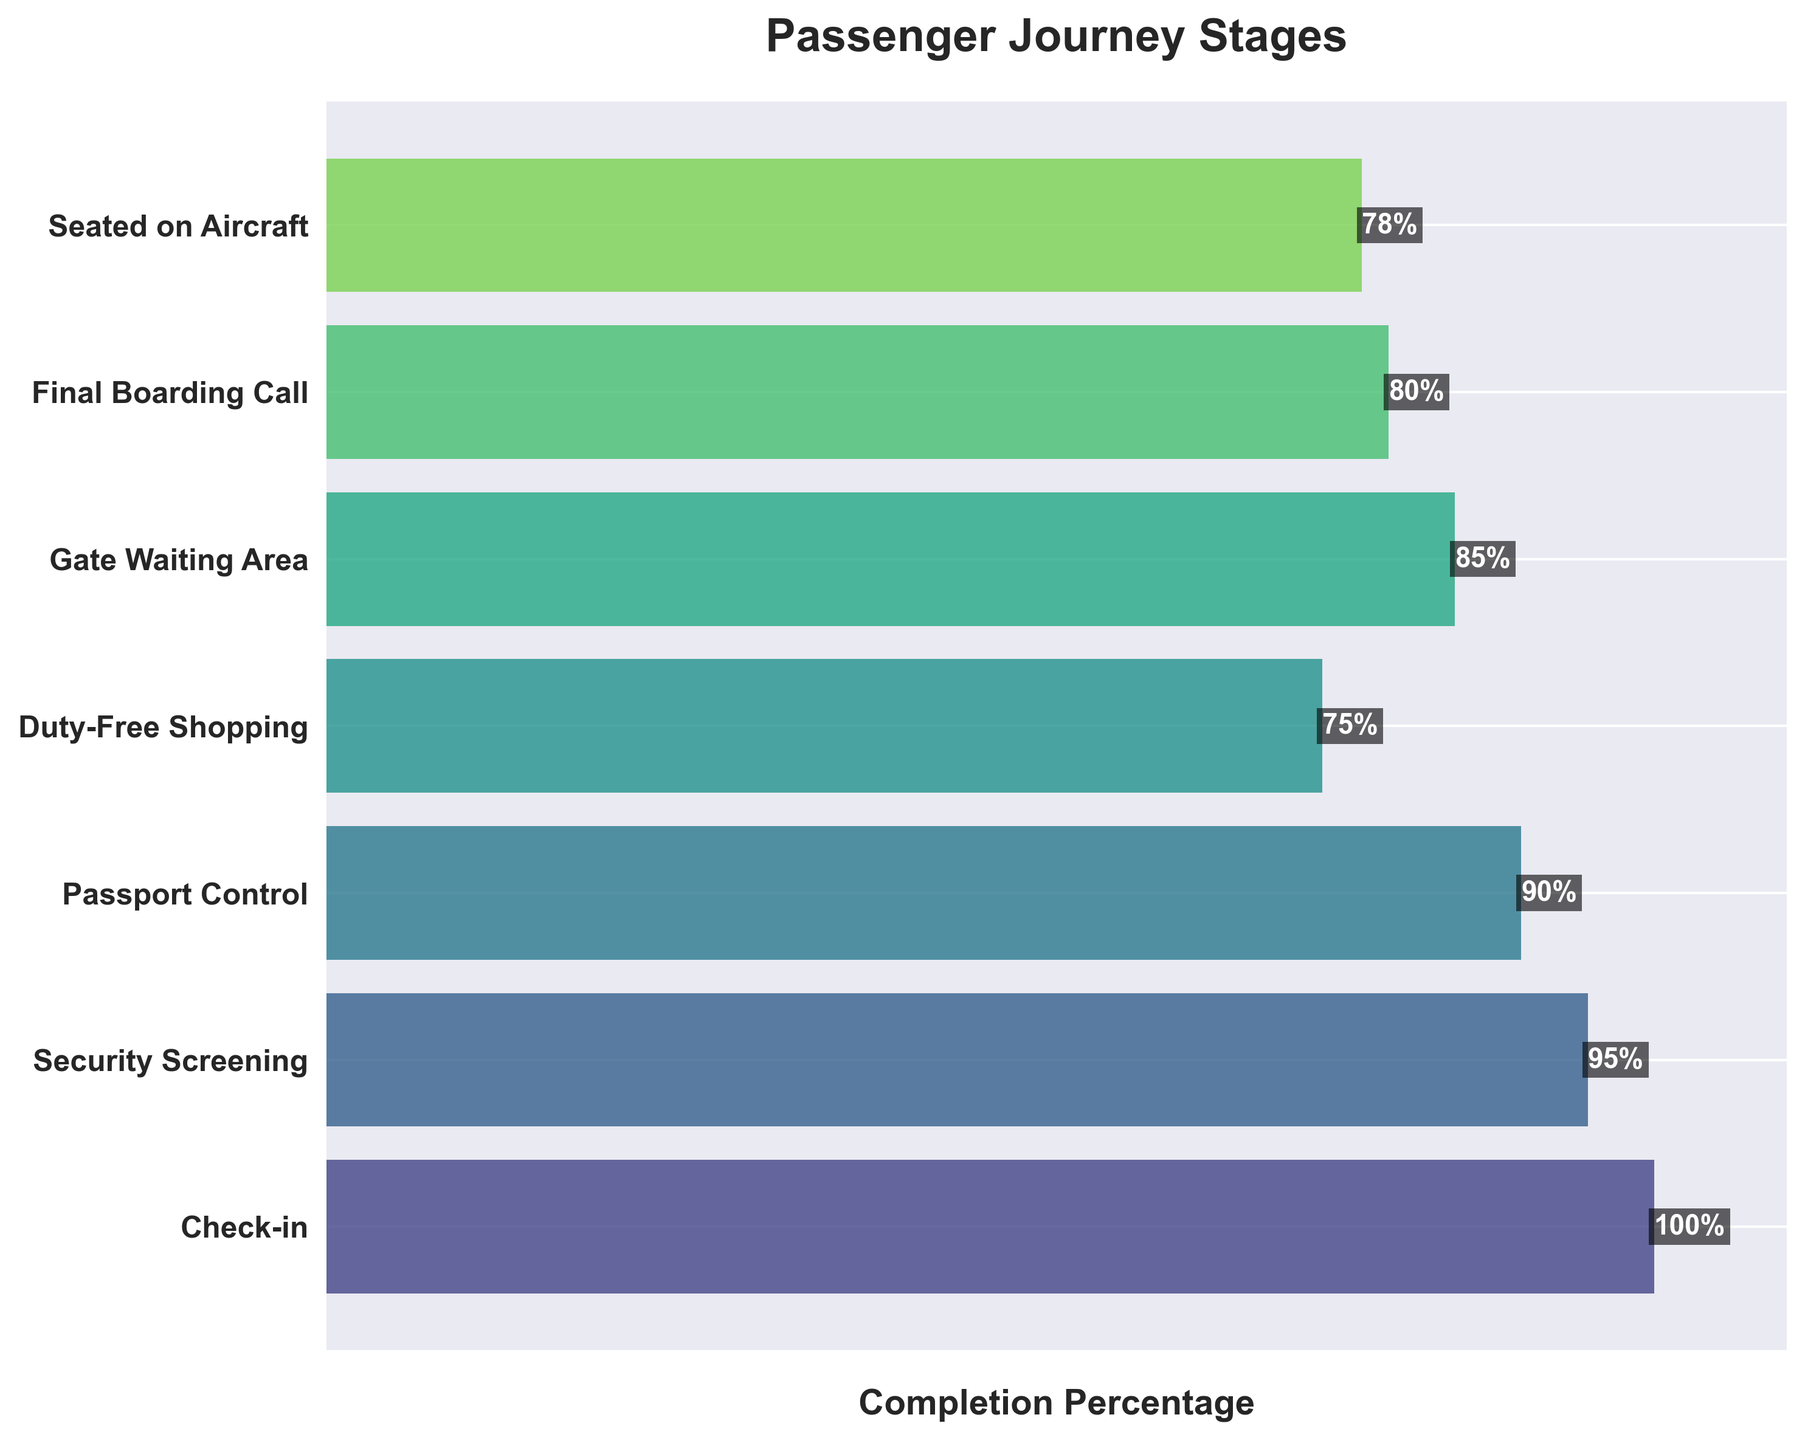What is the title of the figure? The title of the figure is displayed at the top and summarizes the content of the chart.
Answer: Passenger Journey Stages What is the percentage completion at the Security Screening stage? The Security Screening stage is labeled on the y-axis and the percentage completion is shown as a value inside the bar for that stage.
Answer: 95% How many stages are there in total? Count the number of distinct stages listed on the y-axis.
Answer: 7 Which stage has the highest percentage completion? Compare the percentage values indicated at each stage and identify the highest one.
Answer: Check-in Which two stages have the lowest completion percentages? Identify the two smallest percentage values among all stages.
Answer: Duty-Free Shopping and Seated on Aircraft What is the difference in percentage completion between Security Screening and Passport Control? Subtract the percentage completion of Passport Control from Security Screening.
Answer: \(95\% - 90\% = 5\%\) Are there any stages where the percentage completion increases compared to the previous stage? Compare the percentage values of consecutive stages and check for any increase.
Answer: Yes, Gate Waiting Area (85%) is higher than Duty-Free Shopping (75%) What is the average percentage completion from Duty-Free Shopping to Seated on Aircraft? Sum the percentage completions from Duty-Free Shopping to Seated on Aircraft and divide by the number of stages involved.
Answer: \(\frac{75\% + 85\% + 80\% + 78\%}{4} = 79.5\%\) Is the percentage completion at the Final Boarding Call stage greater than at the Gate Waiting Area stage? Compare the percentage values of Final Boarding Call and Gate Waiting Area stages.
Answer: No What percentage of passengers are seated on the aircraft by the end of the journey? Look at the last stage of the journey and state the completion percentage indicated.
Answer: 78% 